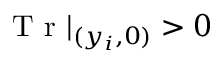<formula> <loc_0><loc_0><loc_500><loc_500>T r | _ { ( y _ { i } , 0 ) } > 0</formula> 